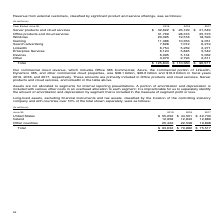According to Microsoft Corporation's financial document, What reason does the company give for not separately identifying the amount of amortization and depreciation by segment? it is impracticable for us to separately identify the amount of amortization and depreciation by segment that is included in the measure of segment profit or loss.. The document states: "r costs in an overhead allocation to each segment; it is impracticable for us to separately identify the amount of amortization and depreciation by se..." Also, How is the portion of amortization and depreciation allocated? A portion of amortization and depreciation is included with various other costs in an overhead allocation to each segment. The document states: "to segments for internal reporting presentations. A portion of amortization and depreciation is included with various other costs in an overhead alloc..." Also, How many countries have Long-lived assets, excluding financial instruments and tax assets, classified by the location of the controlling statutory company and with countriesover 10% of the total assets? Counting the relevant items in the document: United States, Ireland, I find 2 instances. The key data points involved are: Ireland, United States. Also, How many millions of long-lived assets were there in the United States in 2019? According to the financial document, 55,252 (in millions). The relevant text states: "United States $ 55,252 $ 44,501 $ 42,730..." Also, can you calculate: What was the percentage change in the total long-lived assets from 2017 to 2018? To answer this question, I need to perform calculations using the financial data. The calculation is: (79,882-75,517)/75,517, which equals 5.78 (percentage). This is based on the information: "Total $ 93,632 $ 79,882 $ 75,517 Total $ 93,632 $ 79,882 $ 75,517..." The key data points involved are: 75,517, 79,882. Also, How many years during 2017 to 2019 did the long-lived asset amount in Ireland exceed $12,900 million? Based on the analysis, there are 1 instances. The counting process: 12,958. 